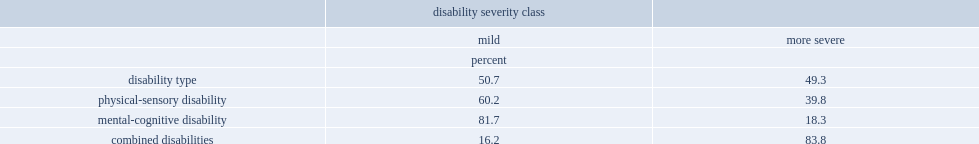What's the proportion of lisa respondents with a disability that had a mild disability? 50.7. What's the proportion of lisa respondents with a disability that had a more severe disability? 49.3. What's the proportion of mental-cognitive disabilities that are mild? 81.7. What's the proportion of combined disabilities that are more severe? 83.8. What's the proportion of mild physical-sensory disabilities? 60.2. What's the proportion of more severe physical-sensory disabilities? 39.8. 